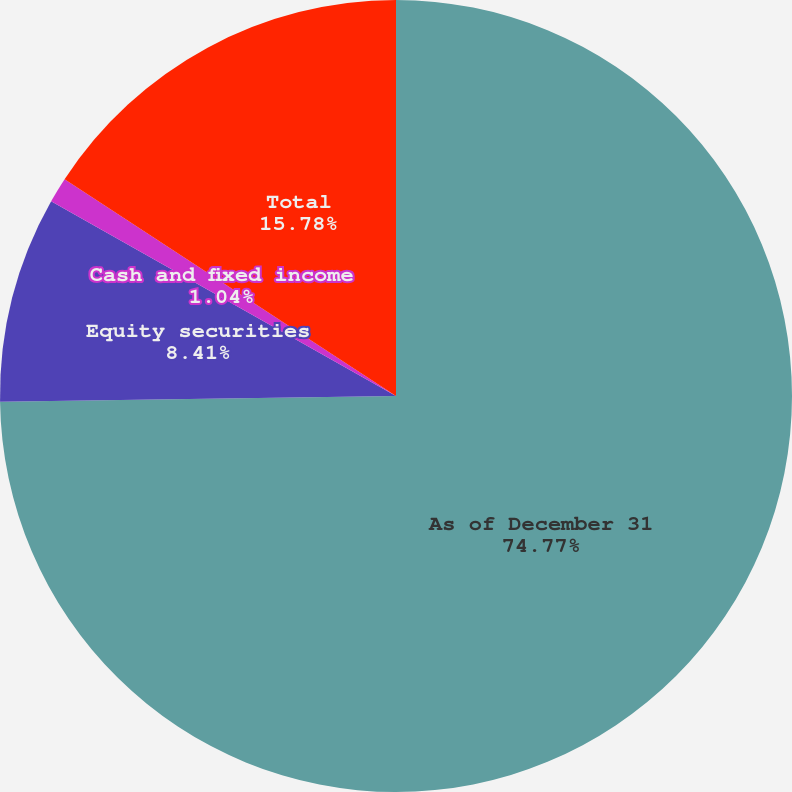<chart> <loc_0><loc_0><loc_500><loc_500><pie_chart><fcel>As of December 31<fcel>Equity securities<fcel>Cash and fixed income<fcel>Total<nl><fcel>74.76%<fcel>8.41%<fcel>1.04%<fcel>15.78%<nl></chart> 